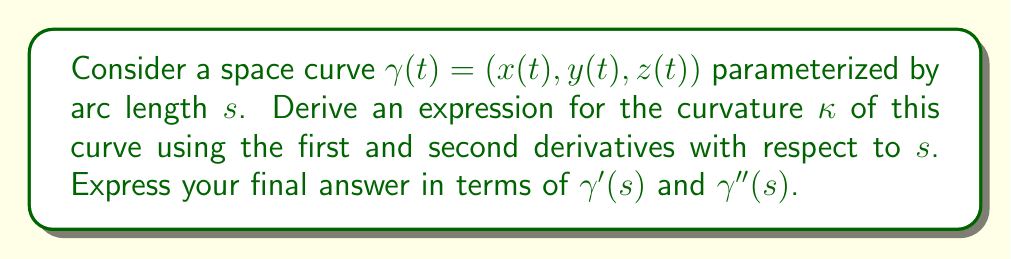Show me your answer to this math problem. Let's approach this step-by-step:

1) First, recall that for a curve parameterized by arc length $s$, we have:
   $$\|\gamma'(s)\| = 1$$

2) The curvature $\kappa$ is defined as the magnitude of the rate of change of the unit tangent vector $T(s)$ with respect to $s$:
   $$\kappa = \left\|\frac{dT}{ds}\right\|$$

3) The unit tangent vector $T(s)$ is given by:
   $$T(s) = \gamma'(s)$$

4) Therefore, we can express curvature as:
   $$\kappa = \|\gamma''(s)\|$$

5) To prove this, let's differentiate $\|\gamma'(s)\| = 1$ with respect to $s$:
   $$\frac{d}{ds}\|\gamma'(s)\|^2 = \frac{d}{ds}(\gamma'(s) \cdot \gamma'(s)) = 0$$

6) Applying the product rule:
   $$2\gamma'(s) \cdot \gamma''(s) = 0$$

7) This means that $\gamma'(s)$ and $\gamma''(s)$ are perpendicular to each other.

8) Now, let's express $\frac{dT}{ds}$:
   $$\frac{dT}{ds} = \frac{d}{ds}\gamma'(s) = \gamma''(s)$$

9) Since $\gamma'(s)$ and $\gamma''(s)$ are perpendicular and $\|\gamma'(s)\| = 1$, we can conclude:
   $$\kappa = \left\|\frac{dT}{ds}\right\| = \|\gamma''(s)\|$$

Thus, we have derived the expression for curvature in terms of $\gamma'(s)$ and $\gamma''(s)$.
Answer: $\kappa = \|\gamma''(s)\|$ 